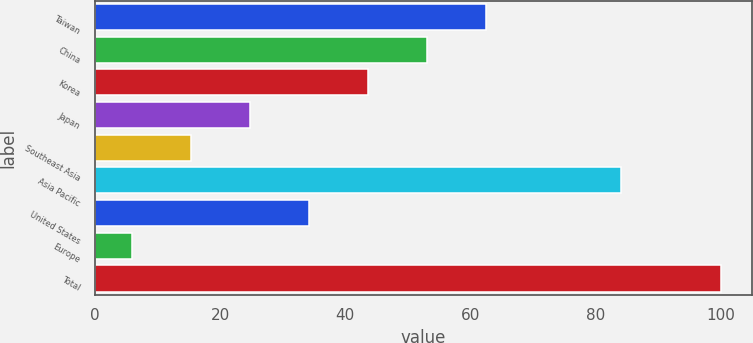<chart> <loc_0><loc_0><loc_500><loc_500><bar_chart><fcel>Taiwan<fcel>China<fcel>Korea<fcel>Japan<fcel>Southeast Asia<fcel>Asia Pacific<fcel>United States<fcel>Europe<fcel>Total<nl><fcel>62.4<fcel>53<fcel>43.6<fcel>24.8<fcel>15.4<fcel>84<fcel>34.2<fcel>6<fcel>100<nl></chart> 